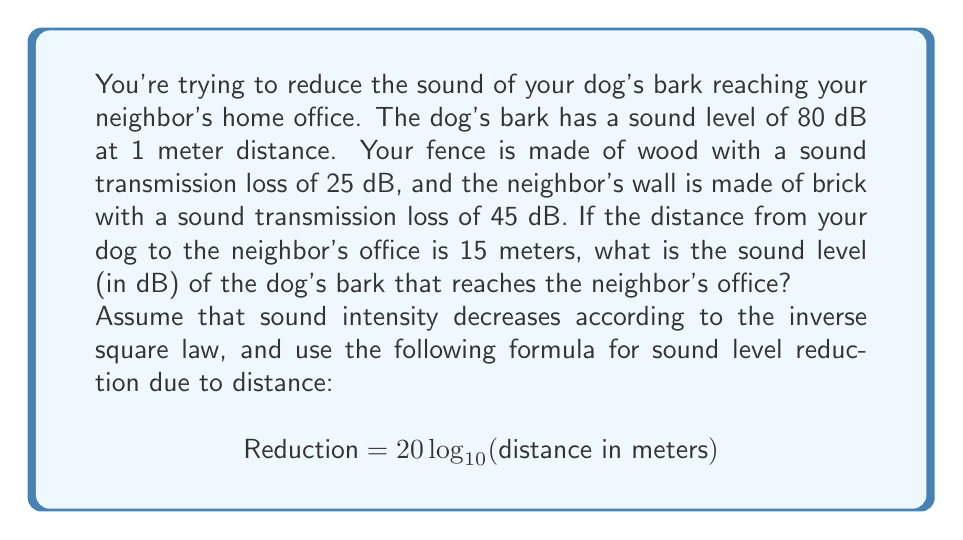Provide a solution to this math problem. To solve this problem, we need to follow these steps:

1. Calculate the sound level reduction due to distance:
   $$ \text{Reduction}_{\text{distance}} = 20 \log_{10}(15) = 20 \times 1.176 = 23.52 \text{ dB} $$

2. Sum up the sound transmission losses:
   $$ \text{Reduction}_{\text{materials}} = 25 \text{ dB (wood)} + 45 \text{ dB (brick)} = 70 \text{ dB} $$

3. Calculate the total reduction:
   $$ \text{Reduction}_{\text{total}} = \text{Reduction}_{\text{distance}} + \text{Reduction}_{\text{materials}} $$
   $$ \text{Reduction}_{\text{total}} = 23.52 + 70 = 93.52 \text{ dB} $$

4. Subtract the total reduction from the initial sound level:
   $$ \text{Sound level}_{\text{final}} = \text{Sound level}_{\text{initial}} - \text{Reduction}_{\text{total}} $$
   $$ \text{Sound level}_{\text{final}} = 80 - 93.52 = -13.52 \text{ dB} $$

However, sound levels below 0 dB are not meaningful in this context. The minimum audible sound level is typically around 0 dB, so we'll round up to 0 dB.
Answer: 0 dB 